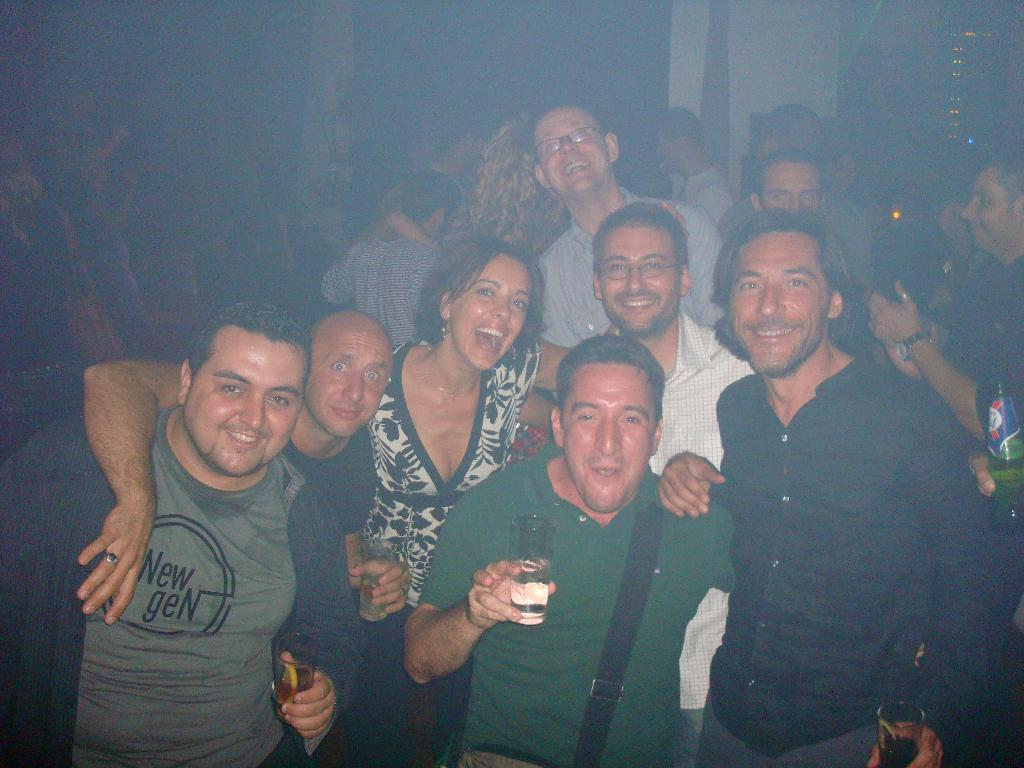What is the main subject of the image? There is a beautiful woman in the image. Where is the woman positioned in the image? The woman is standing in the middle. What is the woman wearing? The woman is wearing a black and white dress. What expression does the woman have? The woman is smiling. What are the men holding in the image? The men are holding wine glasses. How many ducks are present in the image? There are no ducks present in the image. What type of riddle can be solved by looking at the image? There is no riddle present in the image, so it cannot be solved by looking at it. 